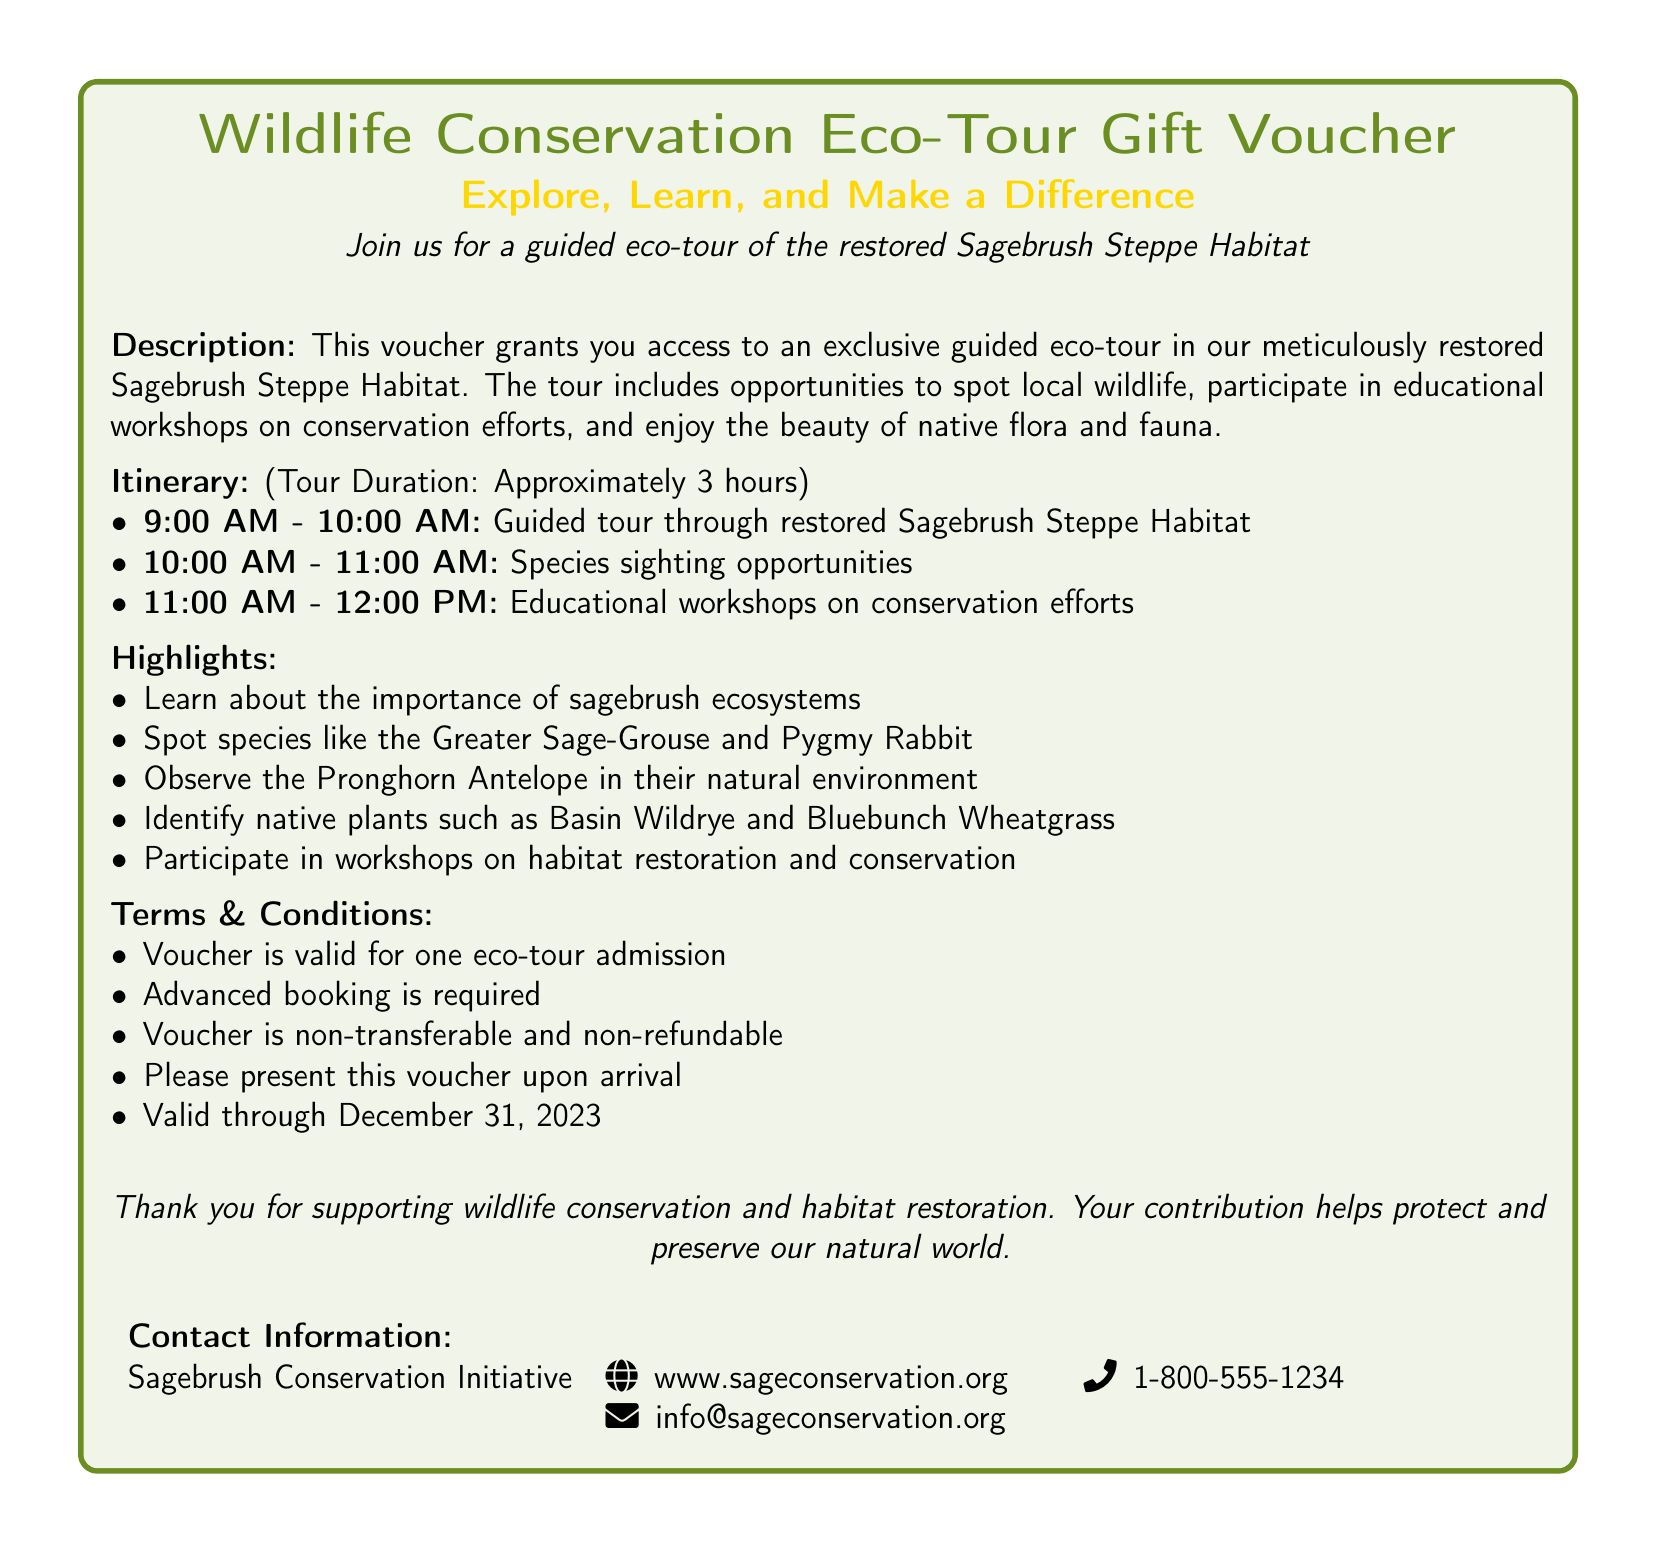What is the title of the voucher? The title is prominently displayed at the top of the voucher.
Answer: Wildlife Conservation Eco-Tour Gift Voucher What habitat will be explored during the eco-tour? The document clearly states the specific habitat to be explored.
Answer: Sagebrush Steppe Habitat How long is the guided eco-tour? The duration of the tour is detailed in the itinerary section.
Answer: Approximately 3 hours What species can participants potentially see during the tour? The highlights mention specific species that can be spotted.
Answer: Greater Sage-Grouse, Pygmy Rabbit, Pronghorn Antelope What is the validity date for the voucher? The terms and conditions section specifies the validity period for the voucher.
Answer: December 31, 2023 What is required for voucher use? The terms clearly mention what is needed upon arrival.
Answer: Presenting the voucher What is the website for the Sagebrush Conservation Initiative? The contact information provides the official website link.
Answer: www.sageconservation.org What are the main activities included in the eco-tour? The itinerary details the scheduled activities during the tour.
Answer: Guided tour, species sighting, educational workshops 